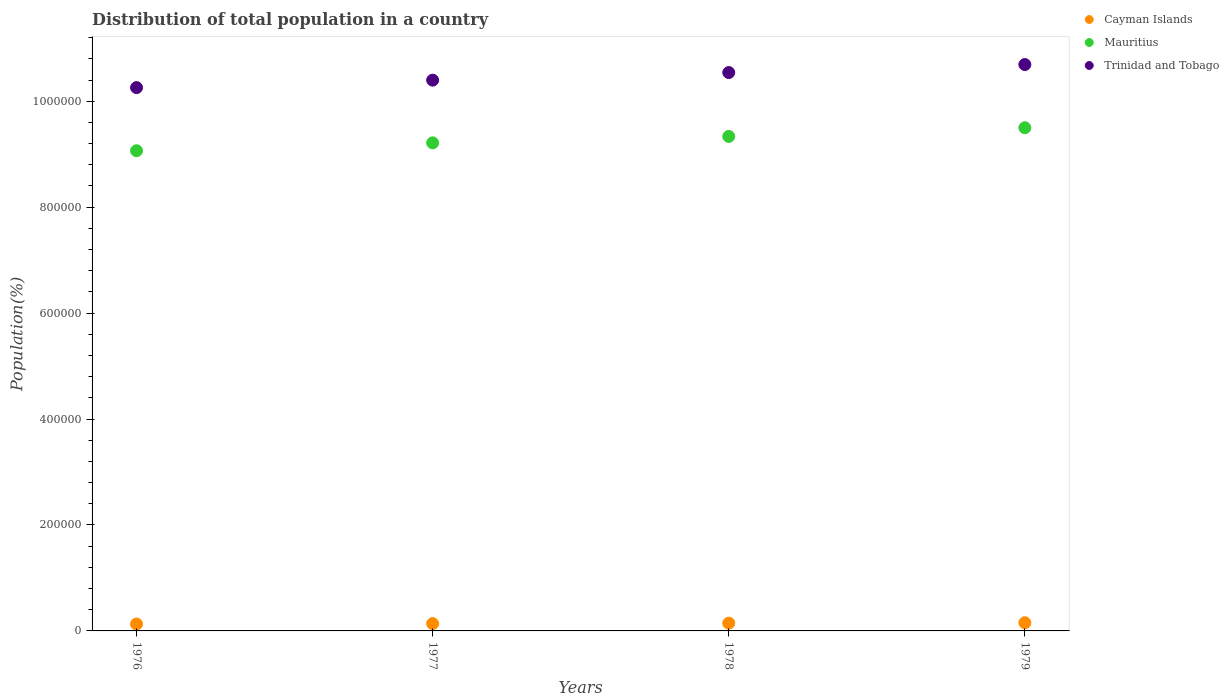How many different coloured dotlines are there?
Your response must be concise. 3. Is the number of dotlines equal to the number of legend labels?
Provide a succinct answer. Yes. What is the population of in Mauritius in 1976?
Your answer should be compact. 9.07e+05. Across all years, what is the maximum population of in Cayman Islands?
Your answer should be very brief. 1.54e+04. Across all years, what is the minimum population of in Cayman Islands?
Your answer should be compact. 1.30e+04. In which year was the population of in Trinidad and Tobago maximum?
Make the answer very short. 1979. In which year was the population of in Trinidad and Tobago minimum?
Make the answer very short. 1976. What is the total population of in Cayman Islands in the graph?
Your answer should be very brief. 5.70e+04. What is the difference between the population of in Cayman Islands in 1977 and that in 1978?
Offer a very short reply. -823. What is the difference between the population of in Trinidad and Tobago in 1978 and the population of in Cayman Islands in 1977?
Your response must be concise. 1.04e+06. What is the average population of in Cayman Islands per year?
Provide a succinct answer. 1.42e+04. In the year 1977, what is the difference between the population of in Mauritius and population of in Trinidad and Tobago?
Provide a short and direct response. -1.18e+05. In how many years, is the population of in Cayman Islands greater than 280000 %?
Make the answer very short. 0. What is the ratio of the population of in Cayman Islands in 1977 to that in 1979?
Ensure brevity in your answer.  0.9. What is the difference between the highest and the second highest population of in Mauritius?
Ensure brevity in your answer.  1.64e+04. What is the difference between the highest and the lowest population of in Trinidad and Tobago?
Your answer should be very brief. 4.35e+04. In how many years, is the population of in Mauritius greater than the average population of in Mauritius taken over all years?
Provide a succinct answer. 2. Is the sum of the population of in Cayman Islands in 1978 and 1979 greater than the maximum population of in Mauritius across all years?
Offer a terse response. No. Is the population of in Cayman Islands strictly greater than the population of in Trinidad and Tobago over the years?
Offer a terse response. No. How many dotlines are there?
Provide a succinct answer. 3. What is the difference between two consecutive major ticks on the Y-axis?
Keep it short and to the point. 2.00e+05. Are the values on the major ticks of Y-axis written in scientific E-notation?
Your response must be concise. No. Does the graph contain any zero values?
Offer a very short reply. No. What is the title of the graph?
Your answer should be compact. Distribution of total population in a country. What is the label or title of the X-axis?
Offer a terse response. Years. What is the label or title of the Y-axis?
Your answer should be very brief. Population(%). What is the Population(%) of Cayman Islands in 1976?
Keep it short and to the point. 1.30e+04. What is the Population(%) in Mauritius in 1976?
Offer a very short reply. 9.07e+05. What is the Population(%) in Trinidad and Tobago in 1976?
Your answer should be very brief. 1.03e+06. What is the Population(%) in Cayman Islands in 1977?
Offer a terse response. 1.38e+04. What is the Population(%) of Mauritius in 1977?
Offer a terse response. 9.21e+05. What is the Population(%) in Trinidad and Tobago in 1977?
Provide a succinct answer. 1.04e+06. What is the Population(%) of Cayman Islands in 1978?
Make the answer very short. 1.47e+04. What is the Population(%) of Mauritius in 1978?
Provide a succinct answer. 9.33e+05. What is the Population(%) of Trinidad and Tobago in 1978?
Provide a short and direct response. 1.05e+06. What is the Population(%) in Cayman Islands in 1979?
Provide a succinct answer. 1.54e+04. What is the Population(%) in Mauritius in 1979?
Your response must be concise. 9.50e+05. What is the Population(%) of Trinidad and Tobago in 1979?
Your answer should be compact. 1.07e+06. Across all years, what is the maximum Population(%) in Cayman Islands?
Give a very brief answer. 1.54e+04. Across all years, what is the maximum Population(%) in Mauritius?
Provide a short and direct response. 9.50e+05. Across all years, what is the maximum Population(%) in Trinidad and Tobago?
Give a very brief answer. 1.07e+06. Across all years, what is the minimum Population(%) of Cayman Islands?
Your response must be concise. 1.30e+04. Across all years, what is the minimum Population(%) in Mauritius?
Your response must be concise. 9.07e+05. Across all years, what is the minimum Population(%) in Trinidad and Tobago?
Make the answer very short. 1.03e+06. What is the total Population(%) in Cayman Islands in the graph?
Make the answer very short. 5.70e+04. What is the total Population(%) in Mauritius in the graph?
Provide a succinct answer. 3.71e+06. What is the total Population(%) in Trinidad and Tobago in the graph?
Make the answer very short. 4.19e+06. What is the difference between the Population(%) of Cayman Islands in 1976 and that in 1977?
Your answer should be very brief. -820. What is the difference between the Population(%) of Mauritius in 1976 and that in 1977?
Provide a short and direct response. -1.49e+04. What is the difference between the Population(%) of Trinidad and Tobago in 1976 and that in 1977?
Your answer should be very brief. -1.41e+04. What is the difference between the Population(%) in Cayman Islands in 1976 and that in 1978?
Offer a very short reply. -1643. What is the difference between the Population(%) in Mauritius in 1976 and that in 1978?
Your answer should be compact. -2.70e+04. What is the difference between the Population(%) of Trinidad and Tobago in 1976 and that in 1978?
Offer a terse response. -2.85e+04. What is the difference between the Population(%) in Cayman Islands in 1976 and that in 1979?
Ensure brevity in your answer.  -2427. What is the difference between the Population(%) in Mauritius in 1976 and that in 1979?
Make the answer very short. -4.34e+04. What is the difference between the Population(%) in Trinidad and Tobago in 1976 and that in 1979?
Offer a terse response. -4.35e+04. What is the difference between the Population(%) of Cayman Islands in 1977 and that in 1978?
Your answer should be compact. -823. What is the difference between the Population(%) of Mauritius in 1977 and that in 1978?
Keep it short and to the point. -1.21e+04. What is the difference between the Population(%) of Trinidad and Tobago in 1977 and that in 1978?
Provide a short and direct response. -1.44e+04. What is the difference between the Population(%) of Cayman Islands in 1977 and that in 1979?
Offer a very short reply. -1607. What is the difference between the Population(%) in Mauritius in 1977 and that in 1979?
Your answer should be compact. -2.85e+04. What is the difference between the Population(%) in Trinidad and Tobago in 1977 and that in 1979?
Give a very brief answer. -2.94e+04. What is the difference between the Population(%) in Cayman Islands in 1978 and that in 1979?
Your answer should be compact. -784. What is the difference between the Population(%) of Mauritius in 1978 and that in 1979?
Keep it short and to the point. -1.64e+04. What is the difference between the Population(%) of Trinidad and Tobago in 1978 and that in 1979?
Give a very brief answer. -1.51e+04. What is the difference between the Population(%) in Cayman Islands in 1976 and the Population(%) in Mauritius in 1977?
Offer a very short reply. -9.08e+05. What is the difference between the Population(%) in Cayman Islands in 1976 and the Population(%) in Trinidad and Tobago in 1977?
Provide a succinct answer. -1.03e+06. What is the difference between the Population(%) in Mauritius in 1976 and the Population(%) in Trinidad and Tobago in 1977?
Offer a very short reply. -1.33e+05. What is the difference between the Population(%) of Cayman Islands in 1976 and the Population(%) of Mauritius in 1978?
Provide a succinct answer. -9.20e+05. What is the difference between the Population(%) of Cayman Islands in 1976 and the Population(%) of Trinidad and Tobago in 1978?
Give a very brief answer. -1.04e+06. What is the difference between the Population(%) of Mauritius in 1976 and the Population(%) of Trinidad and Tobago in 1978?
Offer a very short reply. -1.48e+05. What is the difference between the Population(%) of Cayman Islands in 1976 and the Population(%) of Mauritius in 1979?
Provide a succinct answer. -9.37e+05. What is the difference between the Population(%) of Cayman Islands in 1976 and the Population(%) of Trinidad and Tobago in 1979?
Offer a very short reply. -1.06e+06. What is the difference between the Population(%) in Mauritius in 1976 and the Population(%) in Trinidad and Tobago in 1979?
Your response must be concise. -1.63e+05. What is the difference between the Population(%) of Cayman Islands in 1977 and the Population(%) of Mauritius in 1978?
Provide a short and direct response. -9.20e+05. What is the difference between the Population(%) in Cayman Islands in 1977 and the Population(%) in Trinidad and Tobago in 1978?
Your response must be concise. -1.04e+06. What is the difference between the Population(%) in Mauritius in 1977 and the Population(%) in Trinidad and Tobago in 1978?
Your answer should be very brief. -1.33e+05. What is the difference between the Population(%) of Cayman Islands in 1977 and the Population(%) of Mauritius in 1979?
Your response must be concise. -9.36e+05. What is the difference between the Population(%) of Cayman Islands in 1977 and the Population(%) of Trinidad and Tobago in 1979?
Your answer should be compact. -1.06e+06. What is the difference between the Population(%) in Mauritius in 1977 and the Population(%) in Trinidad and Tobago in 1979?
Provide a succinct answer. -1.48e+05. What is the difference between the Population(%) of Cayman Islands in 1978 and the Population(%) of Mauritius in 1979?
Give a very brief answer. -9.35e+05. What is the difference between the Population(%) in Cayman Islands in 1978 and the Population(%) in Trinidad and Tobago in 1979?
Your answer should be compact. -1.05e+06. What is the difference between the Population(%) of Mauritius in 1978 and the Population(%) of Trinidad and Tobago in 1979?
Make the answer very short. -1.36e+05. What is the average Population(%) in Cayman Islands per year?
Make the answer very short. 1.42e+04. What is the average Population(%) in Mauritius per year?
Give a very brief answer. 9.28e+05. What is the average Population(%) of Trinidad and Tobago per year?
Give a very brief answer. 1.05e+06. In the year 1976, what is the difference between the Population(%) in Cayman Islands and Population(%) in Mauritius?
Ensure brevity in your answer.  -8.93e+05. In the year 1976, what is the difference between the Population(%) of Cayman Islands and Population(%) of Trinidad and Tobago?
Give a very brief answer. -1.01e+06. In the year 1976, what is the difference between the Population(%) of Mauritius and Population(%) of Trinidad and Tobago?
Your answer should be very brief. -1.19e+05. In the year 1977, what is the difference between the Population(%) of Cayman Islands and Population(%) of Mauritius?
Your response must be concise. -9.08e+05. In the year 1977, what is the difference between the Population(%) in Cayman Islands and Population(%) in Trinidad and Tobago?
Provide a succinct answer. -1.03e+06. In the year 1977, what is the difference between the Population(%) in Mauritius and Population(%) in Trinidad and Tobago?
Keep it short and to the point. -1.18e+05. In the year 1978, what is the difference between the Population(%) of Cayman Islands and Population(%) of Mauritius?
Make the answer very short. -9.19e+05. In the year 1978, what is the difference between the Population(%) in Cayman Islands and Population(%) in Trinidad and Tobago?
Give a very brief answer. -1.04e+06. In the year 1978, what is the difference between the Population(%) of Mauritius and Population(%) of Trinidad and Tobago?
Give a very brief answer. -1.21e+05. In the year 1979, what is the difference between the Population(%) of Cayman Islands and Population(%) of Mauritius?
Your response must be concise. -9.34e+05. In the year 1979, what is the difference between the Population(%) in Cayman Islands and Population(%) in Trinidad and Tobago?
Your response must be concise. -1.05e+06. In the year 1979, what is the difference between the Population(%) in Mauritius and Population(%) in Trinidad and Tobago?
Your response must be concise. -1.19e+05. What is the ratio of the Population(%) in Cayman Islands in 1976 to that in 1977?
Ensure brevity in your answer.  0.94. What is the ratio of the Population(%) of Mauritius in 1976 to that in 1977?
Make the answer very short. 0.98. What is the ratio of the Population(%) in Trinidad and Tobago in 1976 to that in 1977?
Your answer should be very brief. 0.99. What is the ratio of the Population(%) in Cayman Islands in 1976 to that in 1978?
Keep it short and to the point. 0.89. What is the ratio of the Population(%) in Mauritius in 1976 to that in 1978?
Keep it short and to the point. 0.97. What is the ratio of the Population(%) in Cayman Islands in 1976 to that in 1979?
Make the answer very short. 0.84. What is the ratio of the Population(%) in Mauritius in 1976 to that in 1979?
Ensure brevity in your answer.  0.95. What is the ratio of the Population(%) in Trinidad and Tobago in 1976 to that in 1979?
Ensure brevity in your answer.  0.96. What is the ratio of the Population(%) of Cayman Islands in 1977 to that in 1978?
Keep it short and to the point. 0.94. What is the ratio of the Population(%) of Trinidad and Tobago in 1977 to that in 1978?
Offer a very short reply. 0.99. What is the ratio of the Population(%) of Cayman Islands in 1977 to that in 1979?
Your answer should be very brief. 0.9. What is the ratio of the Population(%) of Mauritius in 1977 to that in 1979?
Keep it short and to the point. 0.97. What is the ratio of the Population(%) in Trinidad and Tobago in 1977 to that in 1979?
Give a very brief answer. 0.97. What is the ratio of the Population(%) of Cayman Islands in 1978 to that in 1979?
Make the answer very short. 0.95. What is the ratio of the Population(%) in Mauritius in 1978 to that in 1979?
Give a very brief answer. 0.98. What is the ratio of the Population(%) of Trinidad and Tobago in 1978 to that in 1979?
Provide a short and direct response. 0.99. What is the difference between the highest and the second highest Population(%) in Cayman Islands?
Your response must be concise. 784. What is the difference between the highest and the second highest Population(%) of Mauritius?
Your response must be concise. 1.64e+04. What is the difference between the highest and the second highest Population(%) in Trinidad and Tobago?
Give a very brief answer. 1.51e+04. What is the difference between the highest and the lowest Population(%) of Cayman Islands?
Ensure brevity in your answer.  2427. What is the difference between the highest and the lowest Population(%) in Mauritius?
Provide a succinct answer. 4.34e+04. What is the difference between the highest and the lowest Population(%) in Trinidad and Tobago?
Keep it short and to the point. 4.35e+04. 